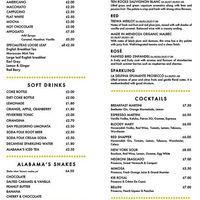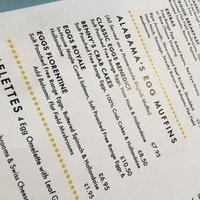The first image is the image on the left, the second image is the image on the right. For the images shown, is this caption "There are exactly two menus." true? Answer yes or no. Yes. The first image is the image on the left, the second image is the image on the right. Examine the images to the left and right. Is the description "A piece of restaurant related paper sits on a wooden surface in one of the images." accurate? Answer yes or no. No. 